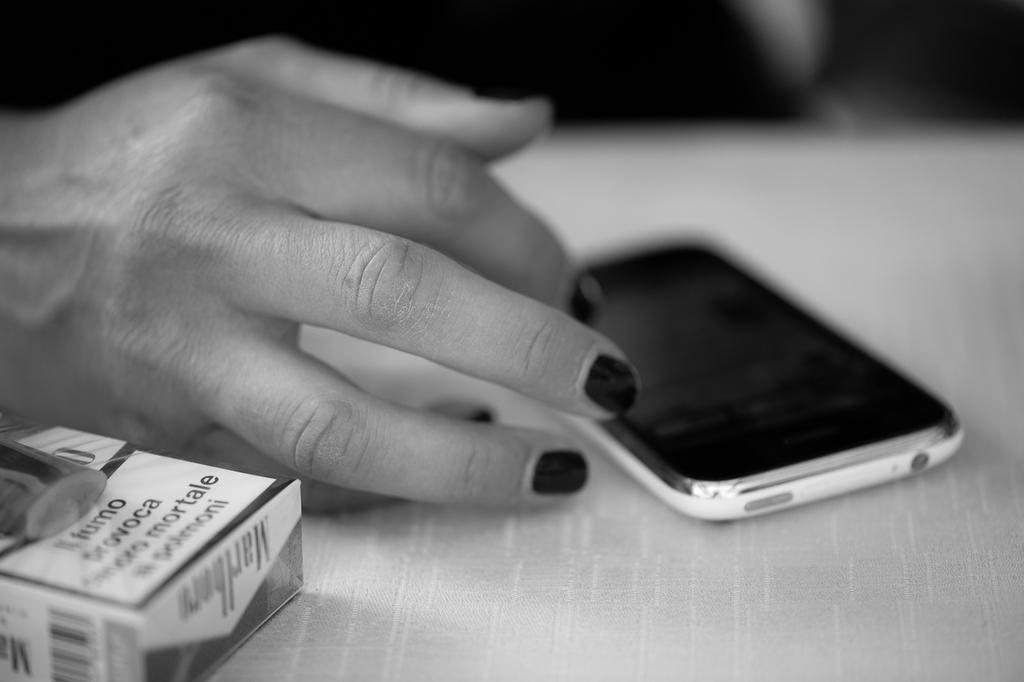<image>
Render a clear and concise summary of the photo. A hand touching a phone with a cigarette carton saying il fumo in the foreground. 